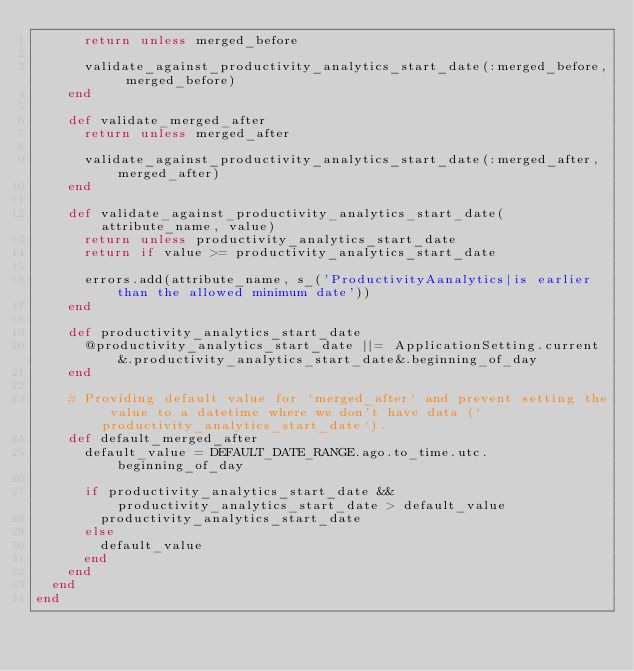<code> <loc_0><loc_0><loc_500><loc_500><_Ruby_>      return unless merged_before

      validate_against_productivity_analytics_start_date(:merged_before, merged_before)
    end

    def validate_merged_after
      return unless merged_after

      validate_against_productivity_analytics_start_date(:merged_after, merged_after)
    end

    def validate_against_productivity_analytics_start_date(attribute_name, value)
      return unless productivity_analytics_start_date
      return if value >= productivity_analytics_start_date

      errors.add(attribute_name, s_('ProductivityAanalytics|is earlier than the allowed minimum date'))
    end

    def productivity_analytics_start_date
      @productivity_analytics_start_date ||= ApplicationSetting.current&.productivity_analytics_start_date&.beginning_of_day
    end

    # Providing default value for `merged_after` and prevent setting the value to a datetime where we don't have data (`productivity_analytics_start_date`).
    def default_merged_after
      default_value = DEFAULT_DATE_RANGE.ago.to_time.utc.beginning_of_day

      if productivity_analytics_start_date && productivity_analytics_start_date > default_value
        productivity_analytics_start_date
      else
        default_value
      end
    end
  end
end
</code> 